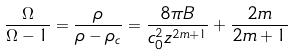Convert formula to latex. <formula><loc_0><loc_0><loc_500><loc_500>\frac { \Omega } { \Omega - 1 } = \frac { \rho } { \rho - \rho _ { c } } = \frac { 8 \pi B } { c _ { 0 } ^ { 2 } z ^ { 2 m + 1 } } + \frac { 2 m } { 2 m + 1 }</formula> 